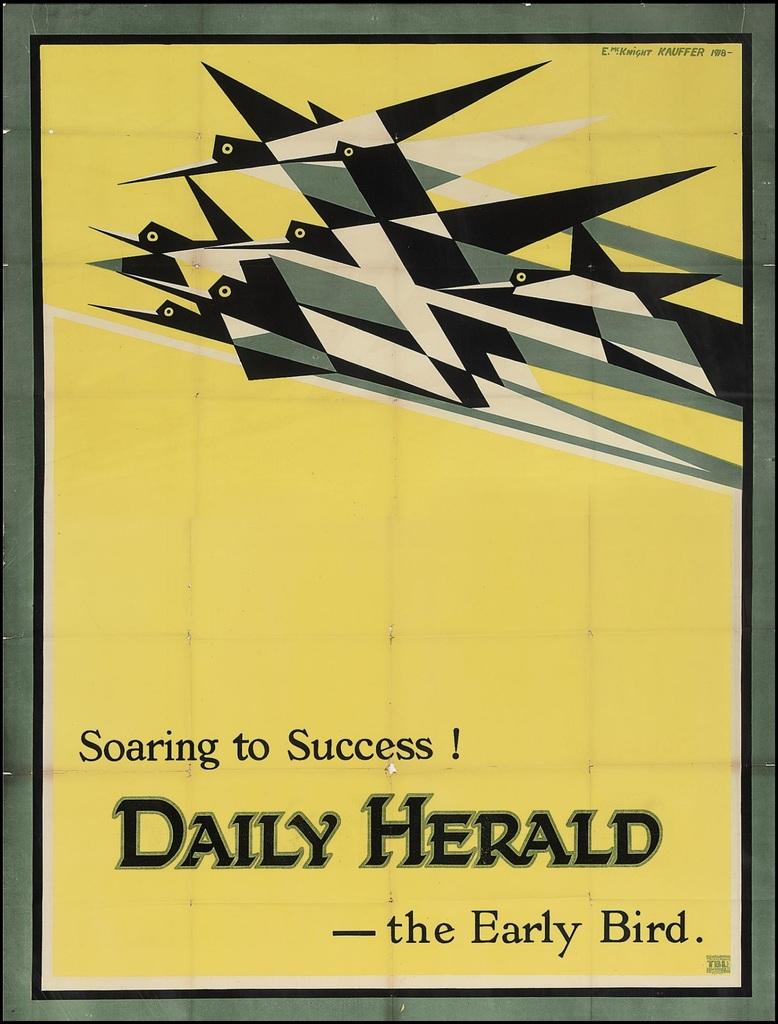Who wrote this?
Ensure brevity in your answer.  The early bird. What type of card is that?
Provide a short and direct response. Unanswerable. 